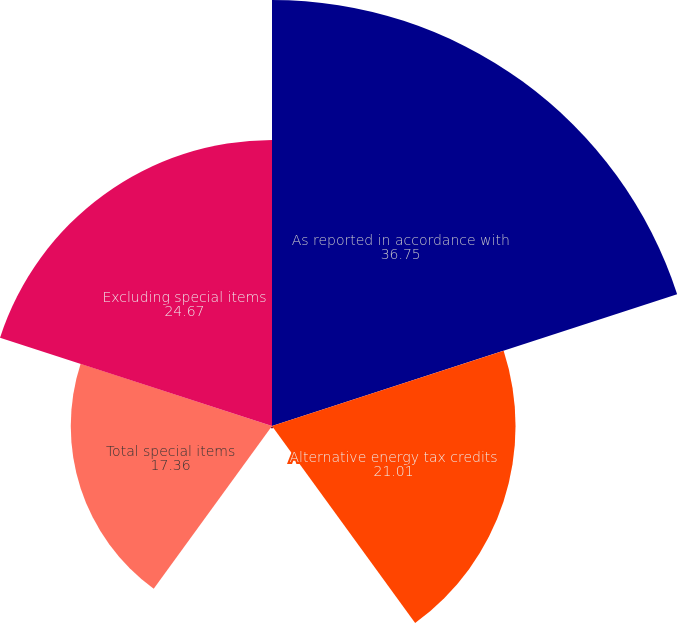Convert chart. <chart><loc_0><loc_0><loc_500><loc_500><pie_chart><fcel>As reported in accordance with<fcel>Alternative energy tax credits<fcel>Asset disposal and facilities<fcel>Total special items<fcel>Excluding special items<nl><fcel>36.75%<fcel>21.01%<fcel>0.2%<fcel>17.36%<fcel>24.67%<nl></chart> 